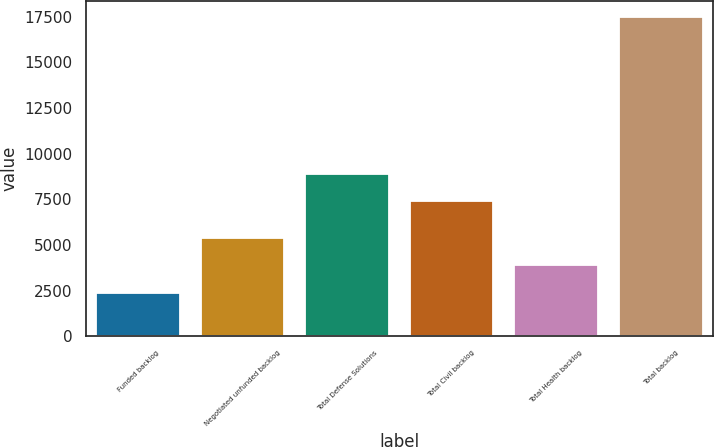<chart> <loc_0><loc_0><loc_500><loc_500><bar_chart><fcel>Funded backlog<fcel>Negotiated unfunded backlog<fcel>Total Defense Solutions<fcel>Total Civil backlog<fcel>Total Health backlog<fcel>Total backlog<nl><fcel>2384<fcel>5402.4<fcel>8894.2<fcel>7385<fcel>3893.2<fcel>17476<nl></chart> 